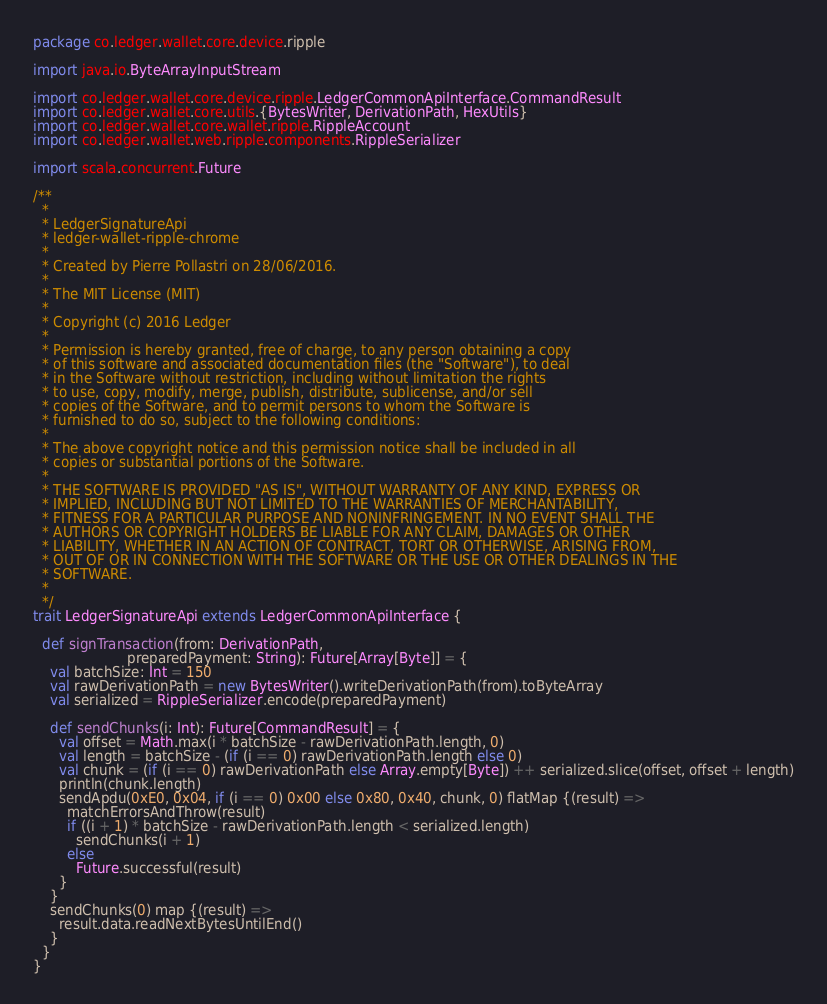<code> <loc_0><loc_0><loc_500><loc_500><_Scala_>package co.ledger.wallet.core.device.ripple

import java.io.ByteArrayInputStream

import co.ledger.wallet.core.device.ripple.LedgerCommonApiInterface.CommandResult
import co.ledger.wallet.core.utils.{BytesWriter, DerivationPath, HexUtils}
import co.ledger.wallet.core.wallet.ripple.RippleAccount
import co.ledger.wallet.web.ripple.components.RippleSerializer

import scala.concurrent.Future

/**
  *
  * LedgerSignatureApi
  * ledger-wallet-ripple-chrome
  *
  * Created by Pierre Pollastri on 28/06/2016.
  *
  * The MIT License (MIT)
  *
  * Copyright (c) 2016 Ledger
  *
  * Permission is hereby granted, free of charge, to any person obtaining a copy
  * of this software and associated documentation files (the "Software"), to deal
  * in the Software without restriction, including without limitation the rights
  * to use, copy, modify, merge, publish, distribute, sublicense, and/or sell
  * copies of the Software, and to permit persons to whom the Software is
  * furnished to do so, subject to the following conditions:
  *
  * The above copyright notice and this permission notice shall be included in all
  * copies or substantial portions of the Software.
  *
  * THE SOFTWARE IS PROVIDED "AS IS", WITHOUT WARRANTY OF ANY KIND, EXPRESS OR
  * IMPLIED, INCLUDING BUT NOT LIMITED TO THE WARRANTIES OF MERCHANTABILITY,
  * FITNESS FOR A PARTICULAR PURPOSE AND NONINFRINGEMENT. IN NO EVENT SHALL THE
  * AUTHORS OR COPYRIGHT HOLDERS BE LIABLE FOR ANY CLAIM, DAMAGES OR OTHER
  * LIABILITY, WHETHER IN AN ACTION OF CONTRACT, TORT OR OTHERWISE, ARISING FROM,
  * OUT OF OR IN CONNECTION WITH THE SOFTWARE OR THE USE OR OTHER DEALINGS IN THE
  * SOFTWARE.
  *
  */
trait LedgerSignatureApi extends LedgerCommonApiInterface {

  def signTransaction(from: DerivationPath,
                      preparedPayment: String): Future[Array[Byte]] = {
    val batchSize: Int = 150
    val rawDerivationPath = new BytesWriter().writeDerivationPath(from).toByteArray
    val serialized = RippleSerializer.encode(preparedPayment)

    def sendChunks(i: Int): Future[CommandResult] = {
      val offset = Math.max(i * batchSize - rawDerivationPath.length, 0)
      val length = batchSize - (if (i == 0) rawDerivationPath.length else 0)
      val chunk = (if (i == 0) rawDerivationPath else Array.empty[Byte]) ++ serialized.slice(offset, offset + length)
      println(chunk.length)
      sendApdu(0xE0, 0x04, if (i == 0) 0x00 else 0x80, 0x40, chunk, 0) flatMap {(result) =>
        matchErrorsAndThrow(result)
        if ((i + 1) * batchSize - rawDerivationPath.length < serialized.length)
          sendChunks(i + 1)
        else
          Future.successful(result)
      }
    }
    sendChunks(0) map {(result) =>
      result.data.readNextBytesUntilEnd()
    }
  }
}</code> 